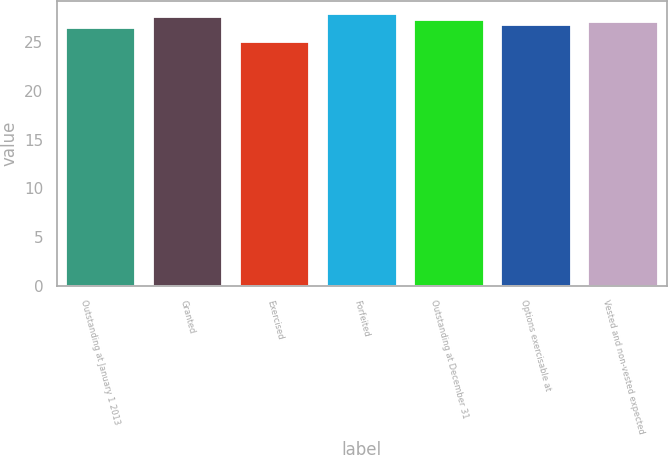<chart> <loc_0><loc_0><loc_500><loc_500><bar_chart><fcel>Outstanding at January 1 2013<fcel>Granted<fcel>Exercised<fcel>Forfeited<fcel>Outstanding at December 31<fcel>Options exercisable at<fcel>Vested and non-vested expected<nl><fcel>26.46<fcel>27.61<fcel>25.01<fcel>27.89<fcel>27.32<fcel>26.75<fcel>27.04<nl></chart> 